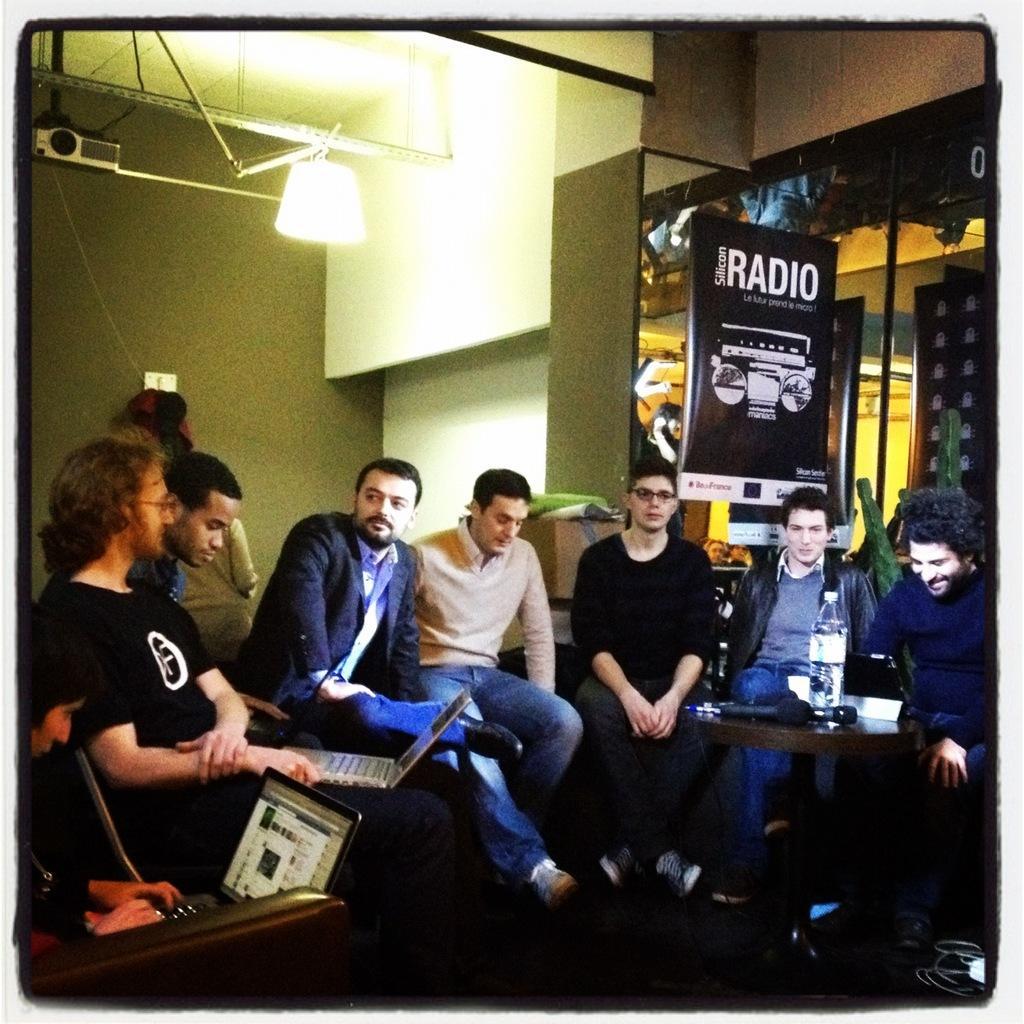Can you describe this image briefly? This is an inside view. Here I can see few men are sitting on the chairs. On the left side two persons are holding laptops in their hands. In the background there is a wall and light. On the right side there is a table on that one bottle and a mike are placed. At the back of these persons there is a board. 